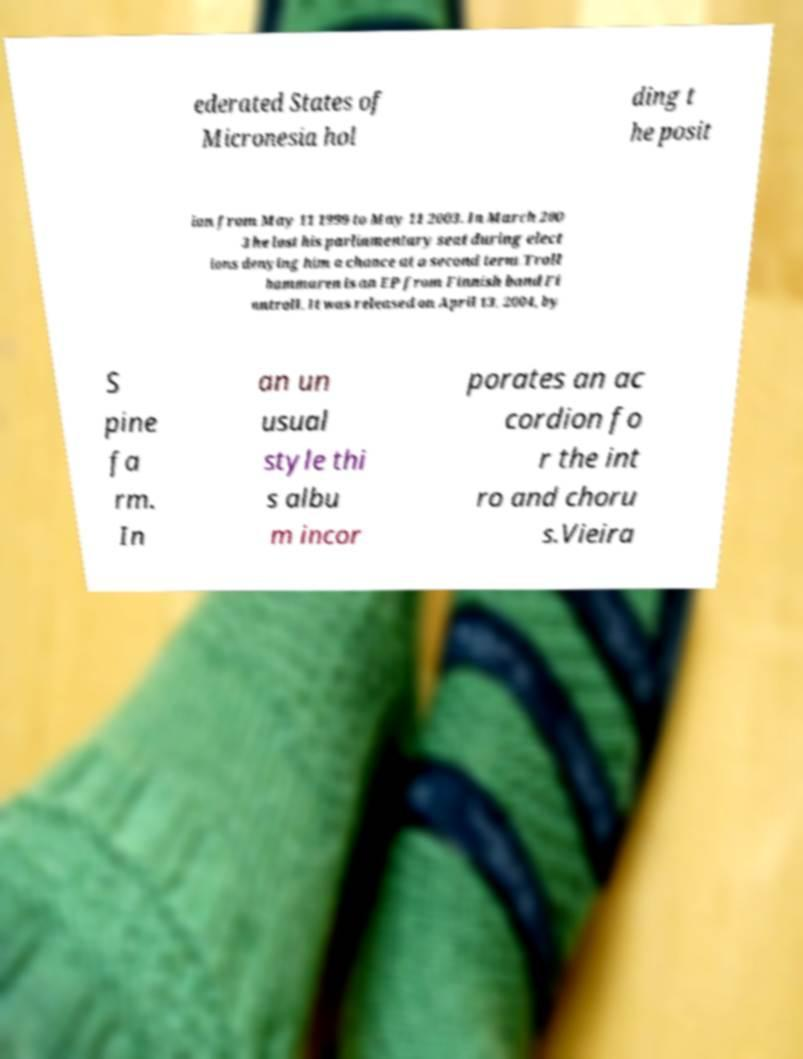Can you accurately transcribe the text from the provided image for me? ederated States of Micronesia hol ding t he posit ion from May 11 1999 to May 11 2003. In March 200 3 he lost his parliamentary seat during elect ions denying him a chance at a second term.Troll hammaren is an EP from Finnish band Fi nntroll. It was released on April 13, 2004, by S pine fa rm. In an un usual style thi s albu m incor porates an ac cordion fo r the int ro and choru s.Vieira 